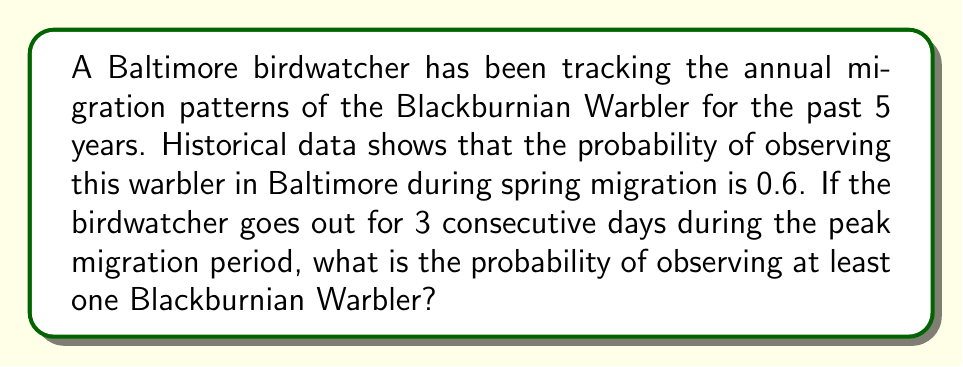Give your solution to this math problem. To solve this problem, we'll use the concept of probability of complement events and the multiplication rule for independent events.

Let's break it down step-by-step:

1. Define the events:
   $A$: Observing at least one Blackburnian Warbler in 3 days
   $A^c$: Not observing any Blackburnian Warbler in 3 days

2. We know that $P(A) + P(A^c) = 1$, so we can find $P(A)$ by calculating $1 - P(A^c)$

3. The probability of not observing the warbler on a single day is:
   $P(\text{not observing}) = 1 - 0.6 = 0.4$

4. For $A^c$ to occur, we need to not observe the warbler for all 3 days. Assuming independence, we can use the multiplication rule:

   $P(A^c) = 0.4 \times 0.4 \times 0.4 = 0.4^3 = 0.064$

5. Now we can calculate $P(A)$:

   $P(A) = 1 - P(A^c) = 1 - 0.064 = 0.936$

Therefore, the probability of observing at least one Blackburnian Warbler in 3 consecutive days is 0.936 or 93.6%.
Answer: $P(\text{observing at least one Blackburnian Warbler in 3 days}) = 0.936$ or $93.6\%$ 